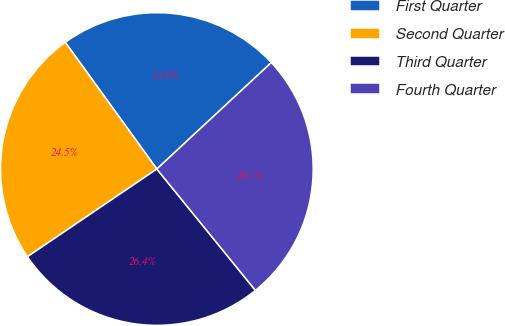<chart> <loc_0><loc_0><loc_500><loc_500><pie_chart><fcel>First Quarter<fcel>Second Quarter<fcel>Third Quarter<fcel>Fourth Quarter<nl><fcel>23.04%<fcel>24.52%<fcel>26.38%<fcel>26.06%<nl></chart> 